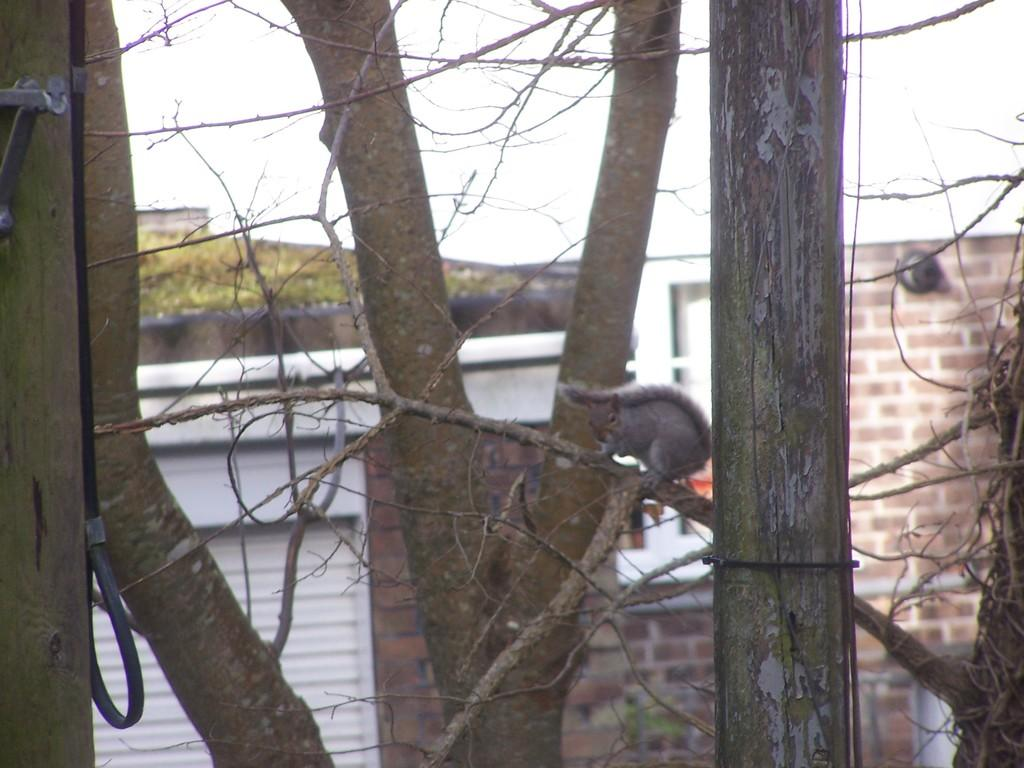What is the main object in the image? There is a tree in the image. What animal can be seen on the tree? A squirrel is on the tree. In which direction is the squirrel facing? The squirrel is facing towards the left side. What can be seen in the background of the image? There are trees and buildings in the background of the image. What is visible at the top of the image? The sky is visible at the top of the image. What type of soup is being served in the image? There is no soup present in the image; it features a tree with a squirrel on it. Can you tell me how many birds are sitting on the branches of the tree? There are no birds present in the image; it only features a squirrel on the tree. 